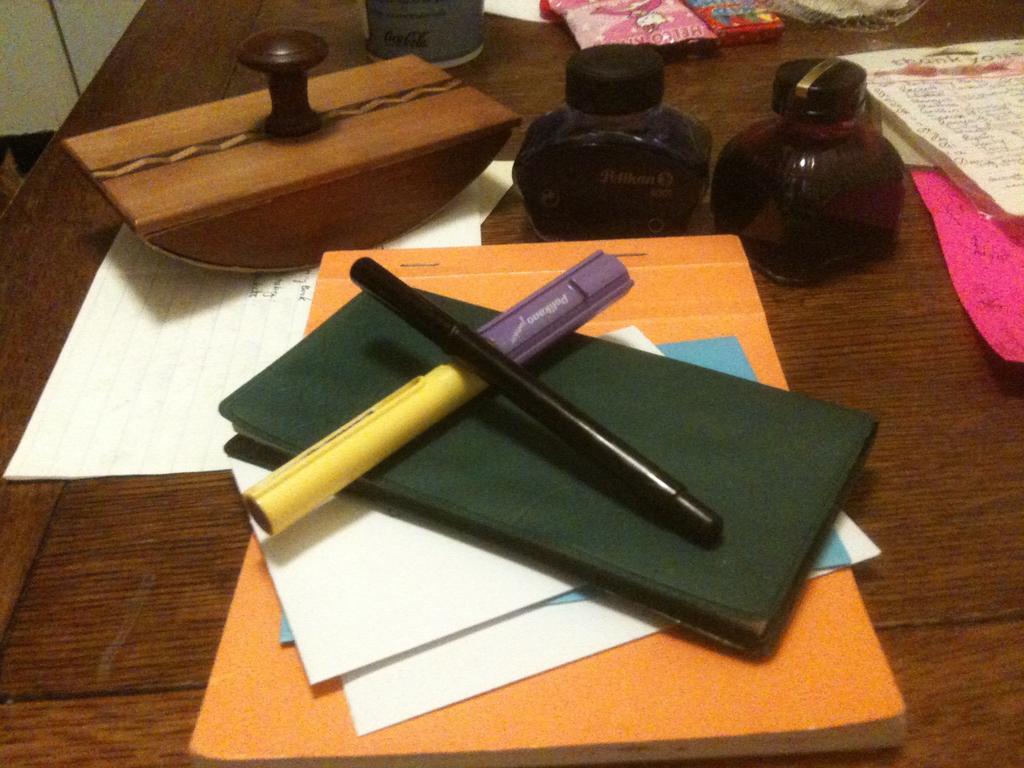Describe this image in one or two sentences. In this picture we can see a pen , marker, wallet and papers on a file. There is a rubber stamp on a paper. We can see bottles and a few objects in the background. 